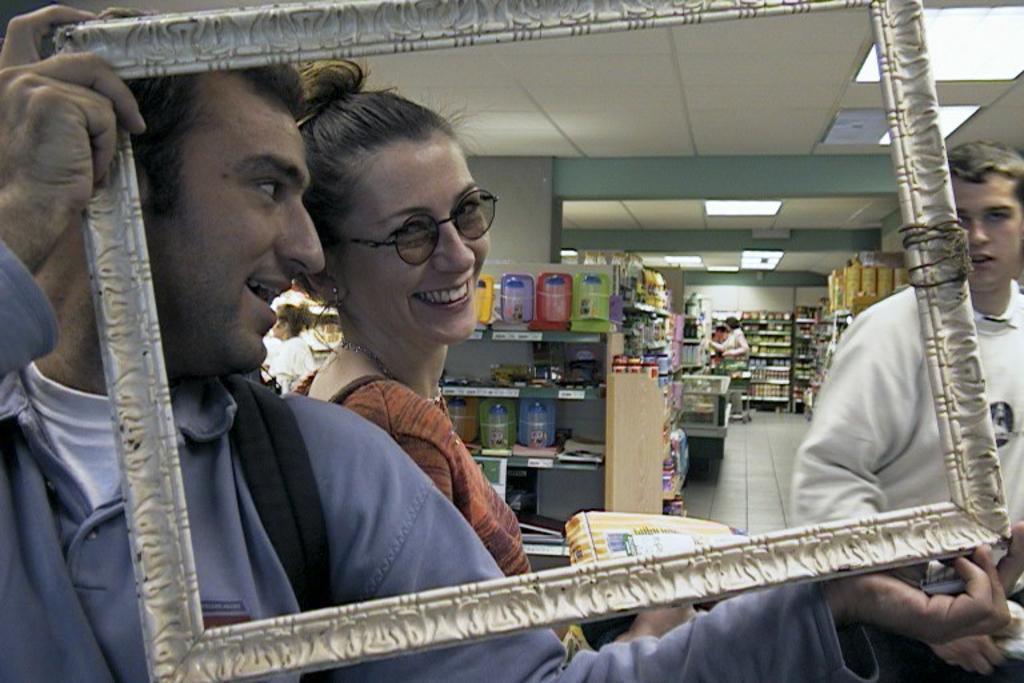Describe this image in one or two sentences. This picture looks like a shopping mall, in this image we can see a few people holding the objects, behind them, we can see some shelves with objects, at the top of the roof, we can see some lights, in the background we can see a person and the wall. 